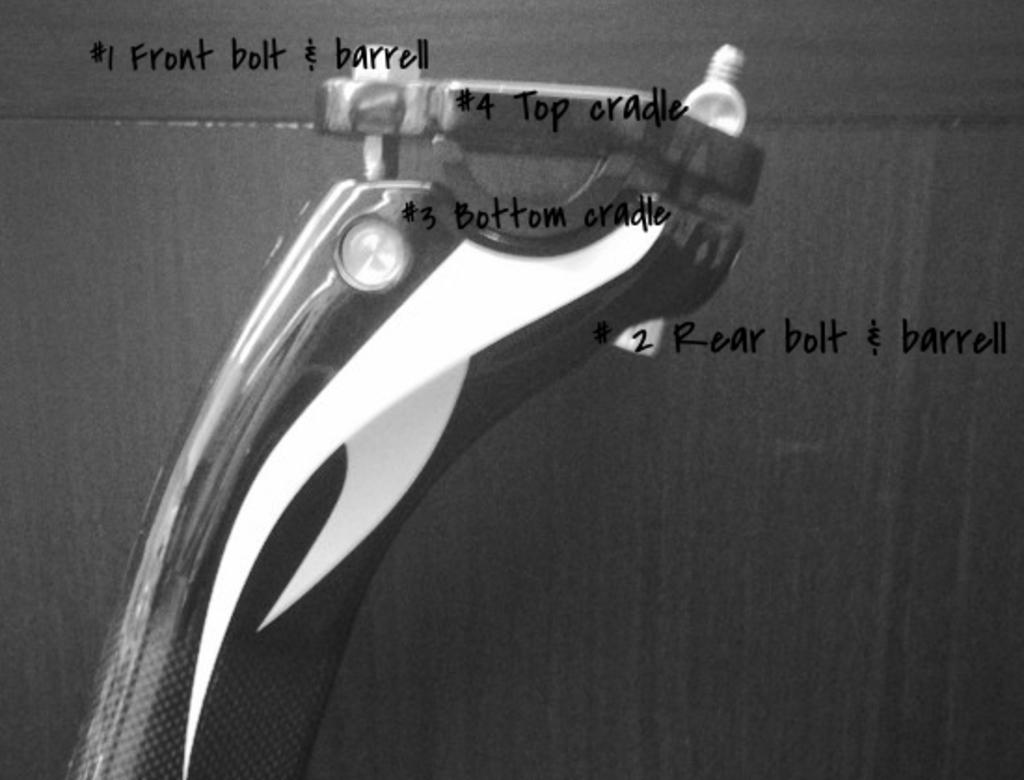What is written at the top side of the image? There is a quotation written at the top side of the image. Can you describe the object behind the quotation? Unfortunately, the provided facts do not give any information about the object behind the quotation. What type of soup is being served in the image? There is no soup present in the image. 